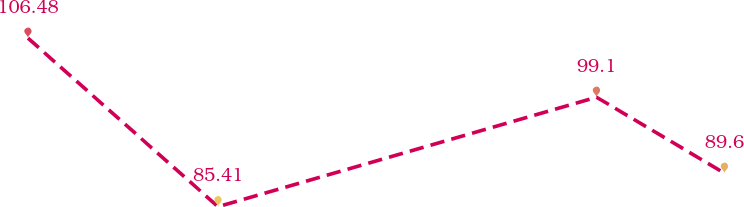Convert chart. <chart><loc_0><loc_0><loc_500><loc_500><line_chart><ecel><fcel>Operating Leases ($ in millions)<nl><fcel>1766.73<fcel>106.48<nl><fcel>1832.98<fcel>85.41<nl><fcel>1964.87<fcel>99.1<nl><fcel>2009.48<fcel>89.6<nl><fcel>2212.85<fcel>64.54<nl></chart> 